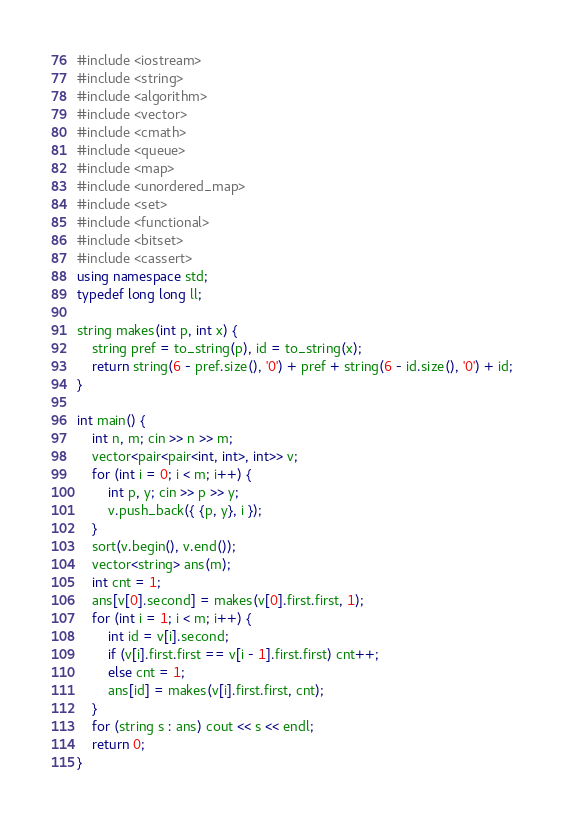<code> <loc_0><loc_0><loc_500><loc_500><_C++_>#include <iostream>
#include <string>
#include <algorithm>
#include <vector>
#include <cmath>
#include <queue>
#include <map>
#include <unordered_map>
#include <set>
#include <functional>
#include <bitset>
#include <cassert>
using namespace std;
typedef long long ll;

string makes(int p, int x) {
	string pref = to_string(p), id = to_string(x);
	return string(6 - pref.size(), '0') + pref + string(6 - id.size(), '0') + id;
}

int main() {
	int n, m; cin >> n >> m;
	vector<pair<pair<int, int>, int>> v;
	for (int i = 0; i < m; i++) {
		int p, y; cin >> p >> y;
		v.push_back({ {p, y}, i });
	}
	sort(v.begin(), v.end());
	vector<string> ans(m);
	int cnt = 1;
	ans[v[0].second] = makes(v[0].first.first, 1);
	for (int i = 1; i < m; i++) {
		int id = v[i].second;
		if (v[i].first.first == v[i - 1].first.first) cnt++;
		else cnt = 1;
		ans[id] = makes(v[i].first.first, cnt);
	}
	for (string s : ans) cout << s << endl;
	return 0;
}
</code> 